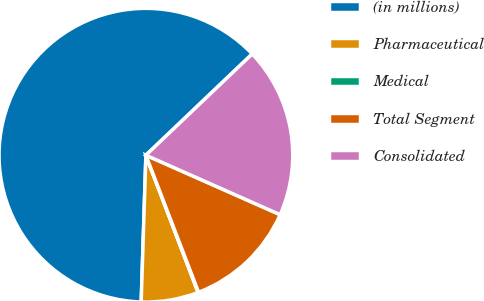Convert chart to OTSL. <chart><loc_0><loc_0><loc_500><loc_500><pie_chart><fcel>(in millions)<fcel>Pharmaceutical<fcel>Medical<fcel>Total Segment<fcel>Consolidated<nl><fcel>62.37%<fcel>6.29%<fcel>0.06%<fcel>12.52%<fcel>18.75%<nl></chart> 